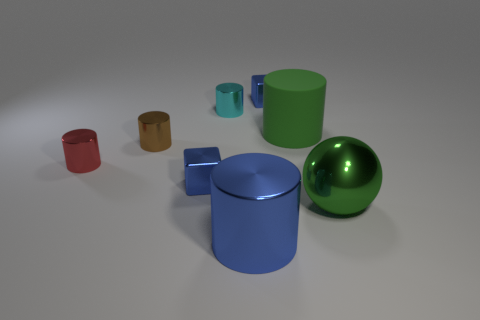The cylinder that is both right of the cyan thing and in front of the brown cylinder is what color?
Your answer should be very brief. Blue. Does the object right of the green matte object have the same size as the small red object?
Ensure brevity in your answer.  No. Is there any other thing that is the same shape as the brown object?
Keep it short and to the point. Yes. Do the brown cylinder and the large thing that is in front of the green sphere have the same material?
Your answer should be very brief. Yes. How many green objects are rubber cylinders or tiny blocks?
Your response must be concise. 1. Is there a small green metallic thing?
Provide a short and direct response. No. Is there a large ball behind the tiny blue metal cube in front of the shiny object that is left of the small brown cylinder?
Offer a very short reply. No. Are there any other things that have the same size as the brown cylinder?
Keep it short and to the point. Yes. There is a green metal thing; is its shape the same as the small blue object behind the tiny brown shiny thing?
Offer a very short reply. No. There is a metallic thing to the right of the blue block that is behind the small blue block that is on the left side of the big blue object; what color is it?
Ensure brevity in your answer.  Green. 